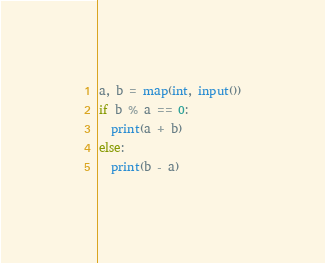<code> <loc_0><loc_0><loc_500><loc_500><_Python_>a, b = map(int, input())
if b % a == 0:
  print(a + b)
else:
  print(b - a)</code> 